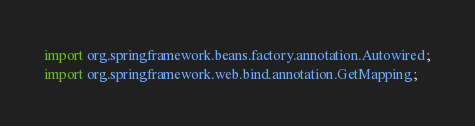<code> <loc_0><loc_0><loc_500><loc_500><_Java_>import org.springframework.beans.factory.annotation.Autowired;
import org.springframework.web.bind.annotation.GetMapping;</code> 